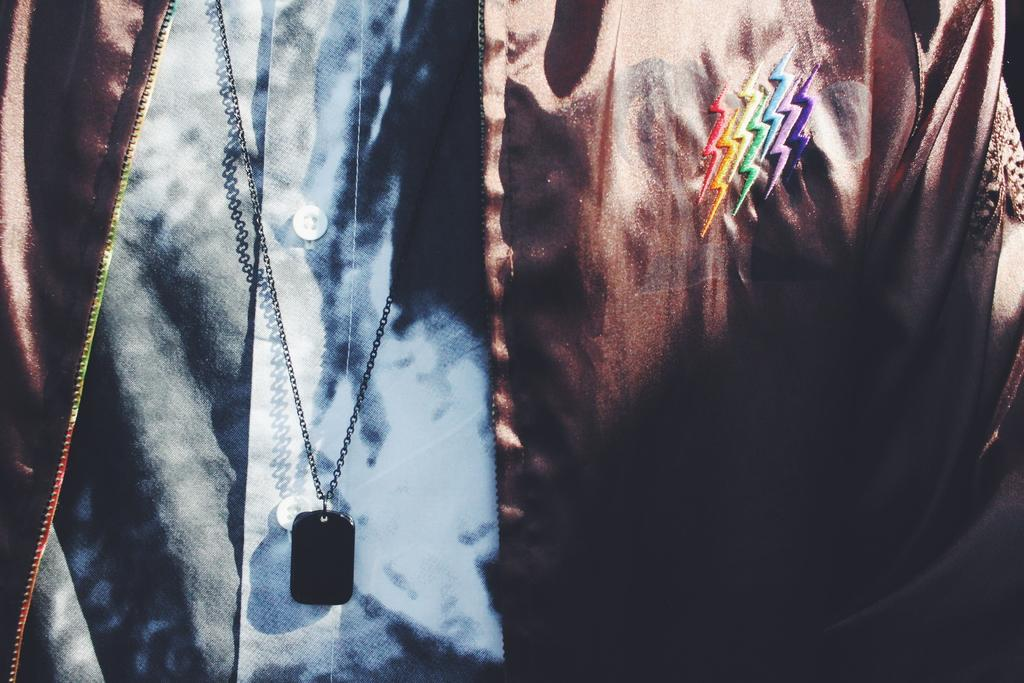What is present in the image? There is a person in the image. What is the person wearing on their upper body? The person is wearing a jacket and a shirt. What type of accessory is the person wearing? The person is wearing a black color chain. What type of thread is being used to sew the tank in the image? There is no tank present in the image, so it is not possible to determine what type of thread might be used for sewing. 